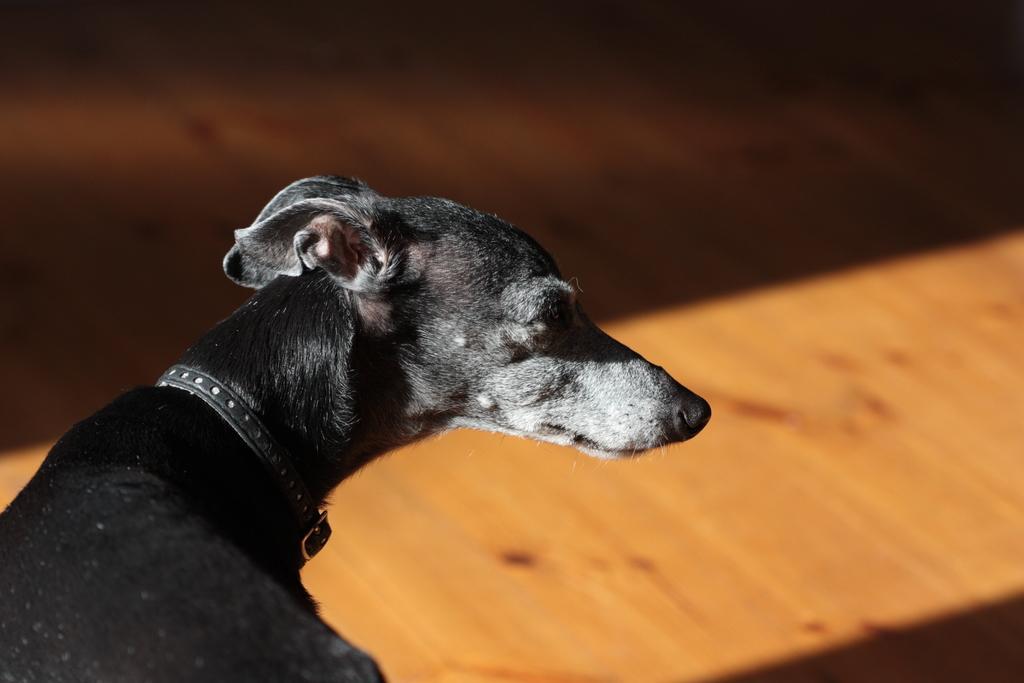How would you summarize this image in a sentence or two? In the picture we can see a black color dog with black color belt to its neck and in front of the dog we can see wooden floor. 